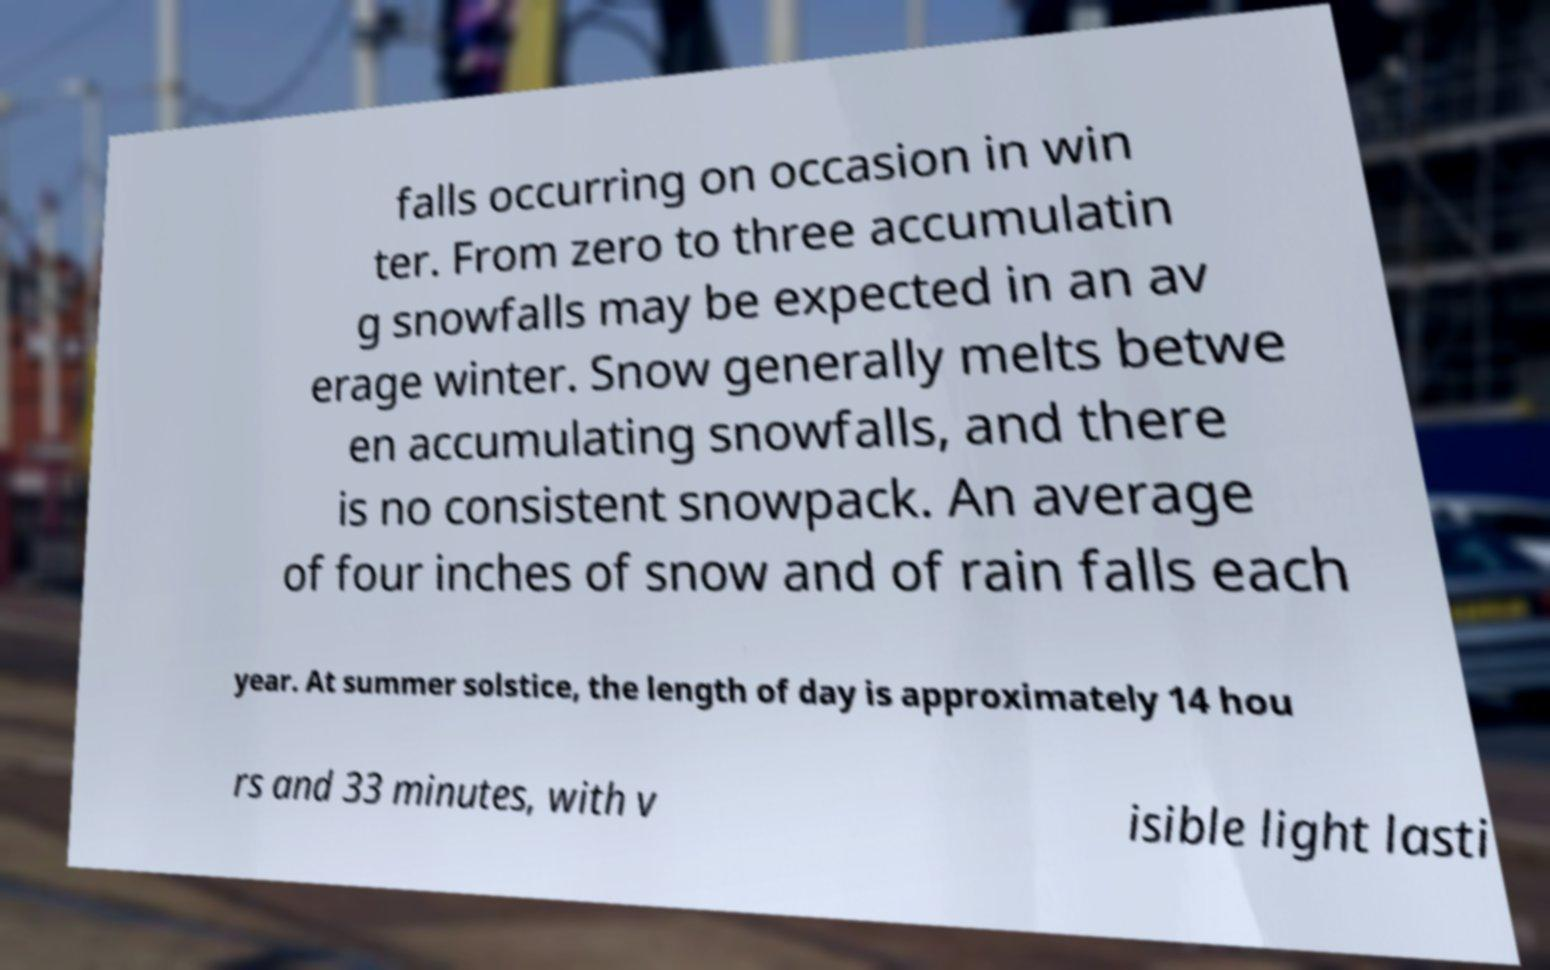For documentation purposes, I need the text within this image transcribed. Could you provide that? falls occurring on occasion in win ter. From zero to three accumulatin g snowfalls may be expected in an av erage winter. Snow generally melts betwe en accumulating snowfalls, and there is no consistent snowpack. An average of four inches of snow and of rain falls each year. At summer solstice, the length of day is approximately 14 hou rs and 33 minutes, with v isible light lasti 